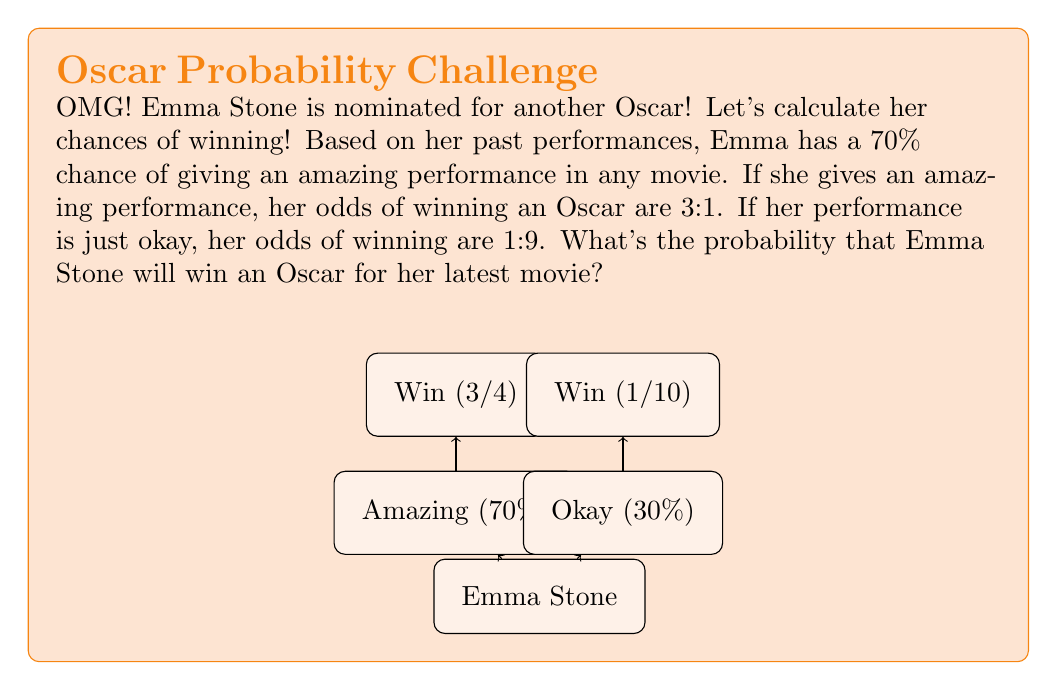Can you answer this question? Let's break this down step-by-step using probability theory:

1) First, we need to define our events:
   A: Emma gives an amazing performance
   W: Emma wins an Oscar

2) We're given the following probabilities:
   $P(A) = 0.70$ (70% chance of amazing performance)
   $P(W|A) = 3/4$ (3:1 odds of winning if amazing)
   $P(W|\text{not }A) = 1/10$ (1:9 odds of winning if okay)

3) We can use the law of total probability:
   $P(W) = P(W|A) \cdot P(A) + P(W|\text{not }A) \cdot P(\text{not }A)$

4) We know $P(A) = 0.70$, so $P(\text{not }A) = 1 - 0.70 = 0.30$

5) Now let's substitute all the values:
   $P(W) = (3/4 \cdot 0.70) + (1/10 \cdot 0.30)$

6) Let's calculate:
   $P(W) = 0.525 + 0.03 = 0.555$

7) Convert to a percentage:
   $0.555 \cdot 100\% = 55.5\%$

Therefore, Emma Stone has a 55.5% chance of winning an Oscar for her latest movie.
Answer: 55.5% 